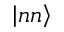Convert formula to latex. <formula><loc_0><loc_0><loc_500><loc_500>\left | n n \right \rangle</formula> 